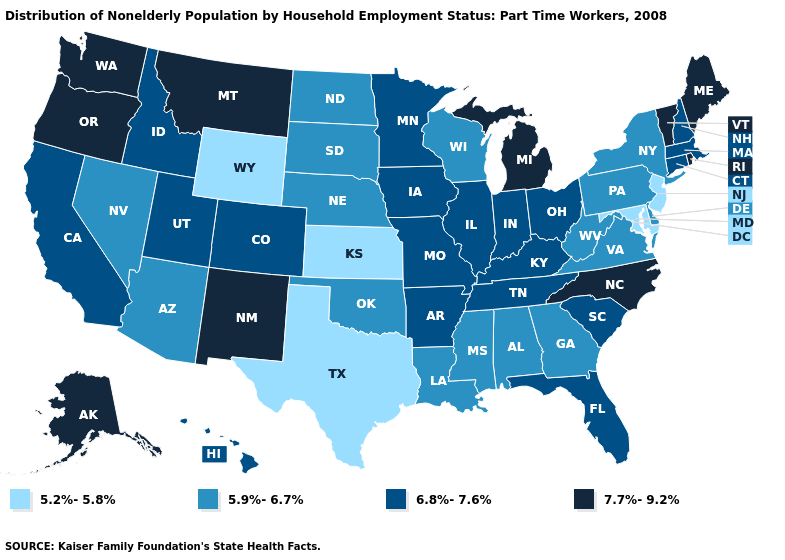How many symbols are there in the legend?
Give a very brief answer. 4. Among the states that border Kentucky , which have the highest value?
Be succinct. Illinois, Indiana, Missouri, Ohio, Tennessee. Does Iowa have the same value as California?
Concise answer only. Yes. Does Alaska have the highest value in the USA?
Answer briefly. Yes. What is the value of Maine?
Keep it brief. 7.7%-9.2%. What is the value of New Jersey?
Short answer required. 5.2%-5.8%. Among the states that border Kansas , does Colorado have the lowest value?
Be succinct. No. What is the lowest value in the Northeast?
Keep it brief. 5.2%-5.8%. What is the value of Hawaii?
Be succinct. 6.8%-7.6%. Does the first symbol in the legend represent the smallest category?
Answer briefly. Yes. Among the states that border Nevada , does Oregon have the highest value?
Be succinct. Yes. Name the states that have a value in the range 5.2%-5.8%?
Short answer required. Kansas, Maryland, New Jersey, Texas, Wyoming. What is the value of Oklahoma?
Concise answer only. 5.9%-6.7%. Name the states that have a value in the range 7.7%-9.2%?
Keep it brief. Alaska, Maine, Michigan, Montana, New Mexico, North Carolina, Oregon, Rhode Island, Vermont, Washington. Which states hav the highest value in the South?
Concise answer only. North Carolina. 